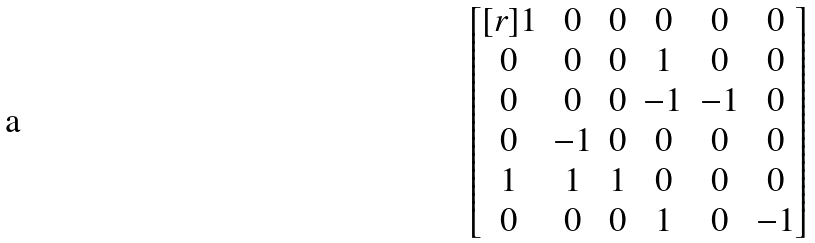<formula> <loc_0><loc_0><loc_500><loc_500>\begin{bmatrix} [ r ] 1 & 0 & 0 & 0 & 0 & 0 \\ 0 & 0 & 0 & 1 & 0 & 0 \\ 0 & 0 & 0 & - 1 & - 1 & 0 \\ 0 & - 1 & 0 & 0 & 0 & 0 \\ 1 & 1 & 1 & 0 & 0 & 0 \\ 0 & 0 & 0 & 1 & 0 & - 1 \\ \end{bmatrix}</formula> 